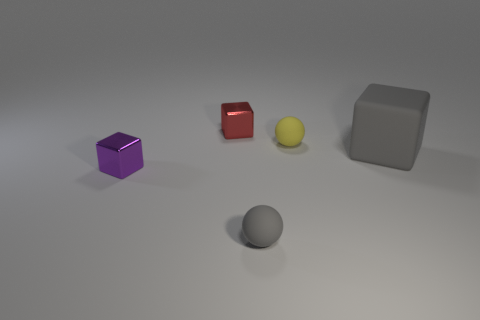How many spheres are behind the purple metal cube? 1 